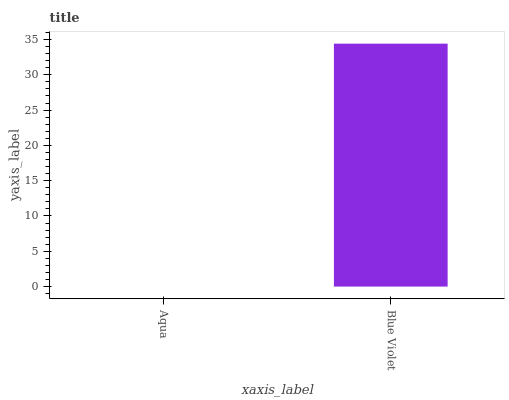Is Aqua the minimum?
Answer yes or no. Yes. Is Blue Violet the maximum?
Answer yes or no. Yes. Is Blue Violet the minimum?
Answer yes or no. No. Is Blue Violet greater than Aqua?
Answer yes or no. Yes. Is Aqua less than Blue Violet?
Answer yes or no. Yes. Is Aqua greater than Blue Violet?
Answer yes or no. No. Is Blue Violet less than Aqua?
Answer yes or no. No. Is Blue Violet the high median?
Answer yes or no. Yes. Is Aqua the low median?
Answer yes or no. Yes. Is Aqua the high median?
Answer yes or no. No. Is Blue Violet the low median?
Answer yes or no. No. 